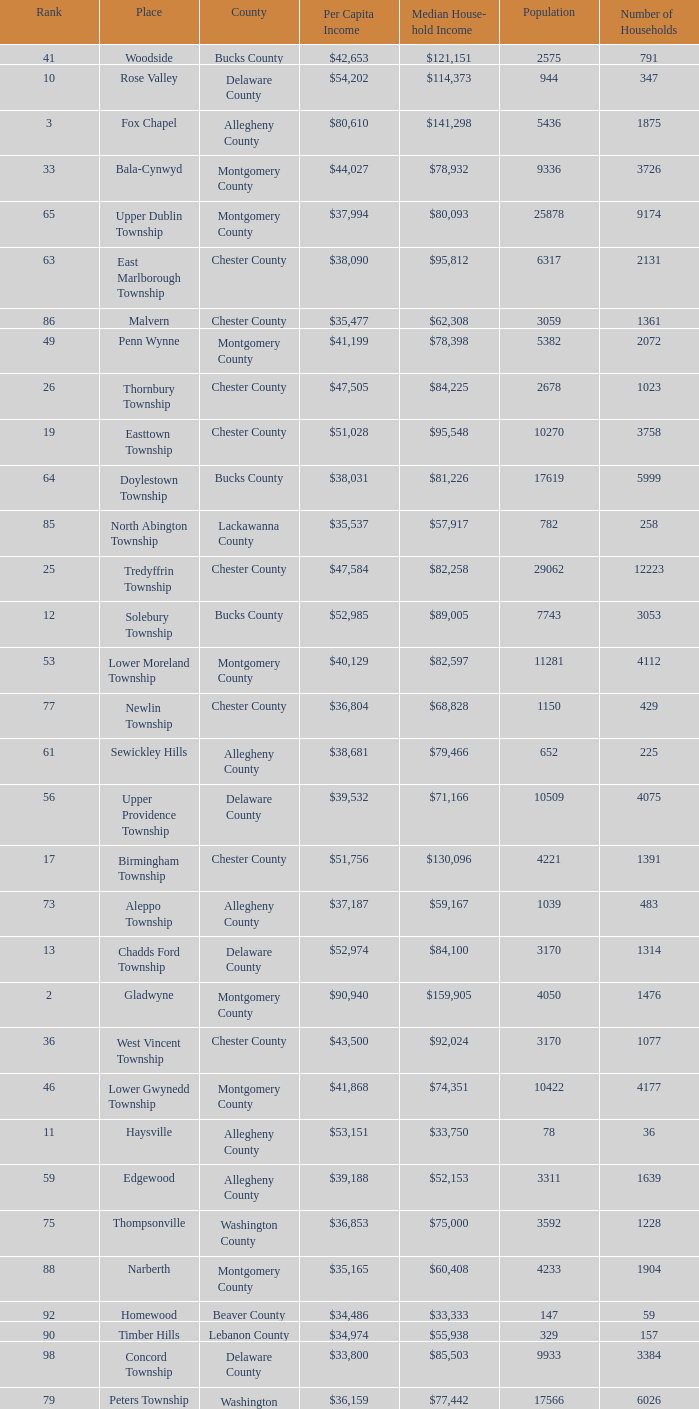Which county has a median household income of  $98,090? Bucks County. 